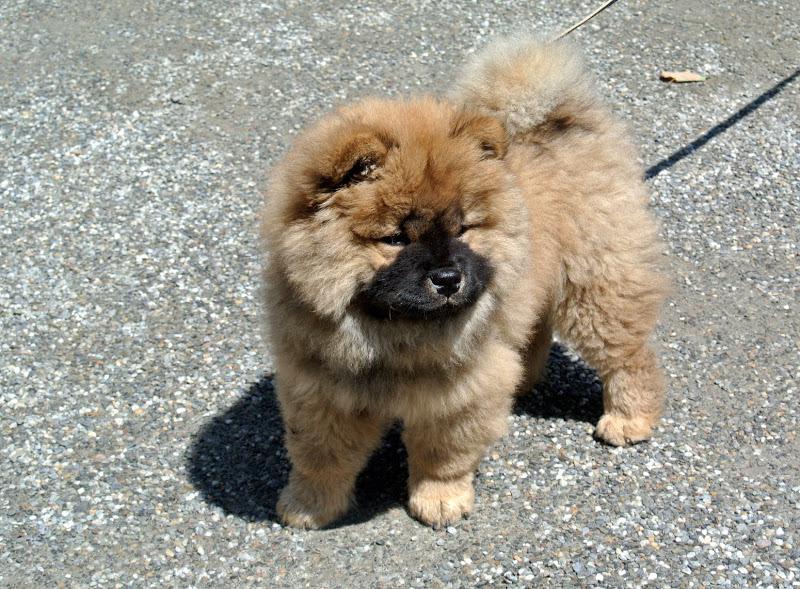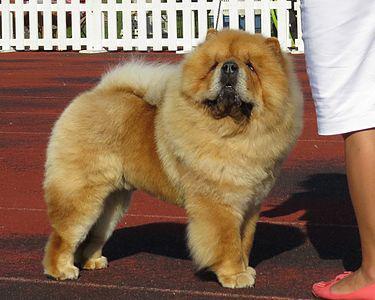The first image is the image on the left, the second image is the image on the right. For the images displayed, is the sentence "At least one dog is standing on hardwood floors." factually correct? Answer yes or no. No. 